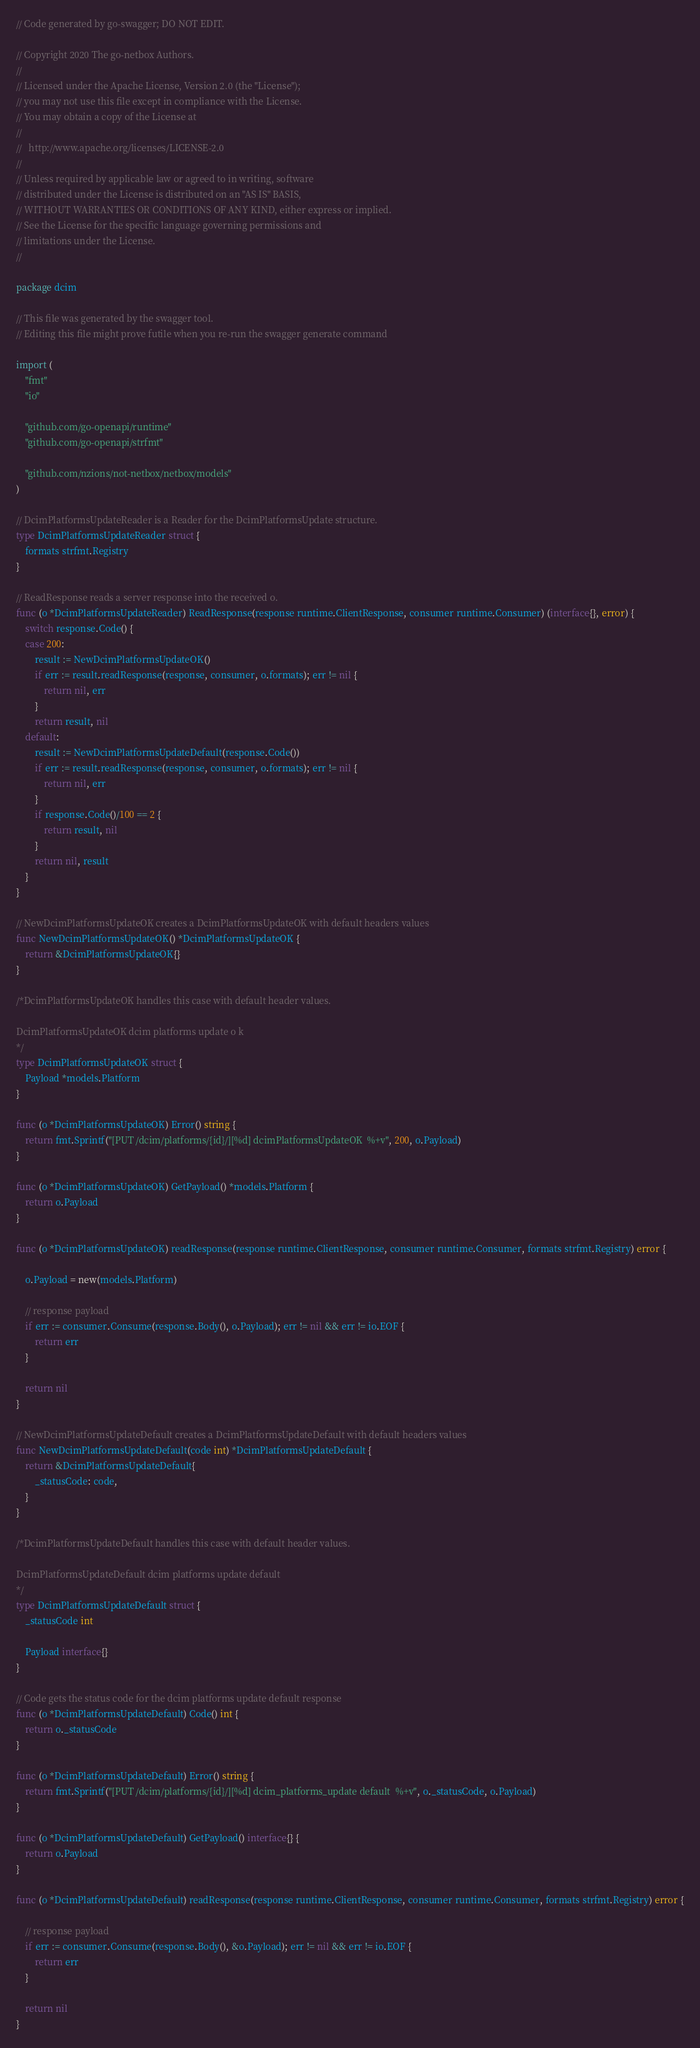<code> <loc_0><loc_0><loc_500><loc_500><_Go_>// Code generated by go-swagger; DO NOT EDIT.

// Copyright 2020 The go-netbox Authors.
//
// Licensed under the Apache License, Version 2.0 (the "License");
// you may not use this file except in compliance with the License.
// You may obtain a copy of the License at
//
//   http://www.apache.org/licenses/LICENSE-2.0
//
// Unless required by applicable law or agreed to in writing, software
// distributed under the License is distributed on an "AS IS" BASIS,
// WITHOUT WARRANTIES OR CONDITIONS OF ANY KIND, either express or implied.
// See the License for the specific language governing permissions and
// limitations under the License.
//

package dcim

// This file was generated by the swagger tool.
// Editing this file might prove futile when you re-run the swagger generate command

import (
	"fmt"
	"io"

	"github.com/go-openapi/runtime"
	"github.com/go-openapi/strfmt"

	"github.com/nzions/not-netbox/netbox/models"
)

// DcimPlatformsUpdateReader is a Reader for the DcimPlatformsUpdate structure.
type DcimPlatformsUpdateReader struct {
	formats strfmt.Registry
}

// ReadResponse reads a server response into the received o.
func (o *DcimPlatformsUpdateReader) ReadResponse(response runtime.ClientResponse, consumer runtime.Consumer) (interface{}, error) {
	switch response.Code() {
	case 200:
		result := NewDcimPlatformsUpdateOK()
		if err := result.readResponse(response, consumer, o.formats); err != nil {
			return nil, err
		}
		return result, nil
	default:
		result := NewDcimPlatformsUpdateDefault(response.Code())
		if err := result.readResponse(response, consumer, o.formats); err != nil {
			return nil, err
		}
		if response.Code()/100 == 2 {
			return result, nil
		}
		return nil, result
	}
}

// NewDcimPlatformsUpdateOK creates a DcimPlatformsUpdateOK with default headers values
func NewDcimPlatformsUpdateOK() *DcimPlatformsUpdateOK {
	return &DcimPlatformsUpdateOK{}
}

/*DcimPlatformsUpdateOK handles this case with default header values.

DcimPlatformsUpdateOK dcim platforms update o k
*/
type DcimPlatformsUpdateOK struct {
	Payload *models.Platform
}

func (o *DcimPlatformsUpdateOK) Error() string {
	return fmt.Sprintf("[PUT /dcim/platforms/{id}/][%d] dcimPlatformsUpdateOK  %+v", 200, o.Payload)
}

func (o *DcimPlatformsUpdateOK) GetPayload() *models.Platform {
	return o.Payload
}

func (o *DcimPlatformsUpdateOK) readResponse(response runtime.ClientResponse, consumer runtime.Consumer, formats strfmt.Registry) error {

	o.Payload = new(models.Platform)

	// response payload
	if err := consumer.Consume(response.Body(), o.Payload); err != nil && err != io.EOF {
		return err
	}

	return nil
}

// NewDcimPlatformsUpdateDefault creates a DcimPlatformsUpdateDefault with default headers values
func NewDcimPlatformsUpdateDefault(code int) *DcimPlatformsUpdateDefault {
	return &DcimPlatformsUpdateDefault{
		_statusCode: code,
	}
}

/*DcimPlatformsUpdateDefault handles this case with default header values.

DcimPlatformsUpdateDefault dcim platforms update default
*/
type DcimPlatformsUpdateDefault struct {
	_statusCode int

	Payload interface{}
}

// Code gets the status code for the dcim platforms update default response
func (o *DcimPlatformsUpdateDefault) Code() int {
	return o._statusCode
}

func (o *DcimPlatformsUpdateDefault) Error() string {
	return fmt.Sprintf("[PUT /dcim/platforms/{id}/][%d] dcim_platforms_update default  %+v", o._statusCode, o.Payload)
}

func (o *DcimPlatformsUpdateDefault) GetPayload() interface{} {
	return o.Payload
}

func (o *DcimPlatformsUpdateDefault) readResponse(response runtime.ClientResponse, consumer runtime.Consumer, formats strfmt.Registry) error {

	// response payload
	if err := consumer.Consume(response.Body(), &o.Payload); err != nil && err != io.EOF {
		return err
	}

	return nil
}
</code> 